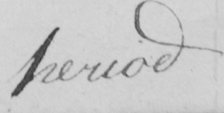What text is written in this handwritten line? period 